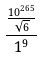Convert formula to latex. <formula><loc_0><loc_0><loc_500><loc_500>\frac { \frac { 1 0 ^ { 2 6 5 } } { \sqrt { 6 } } } { 1 ^ { 9 } }</formula> 